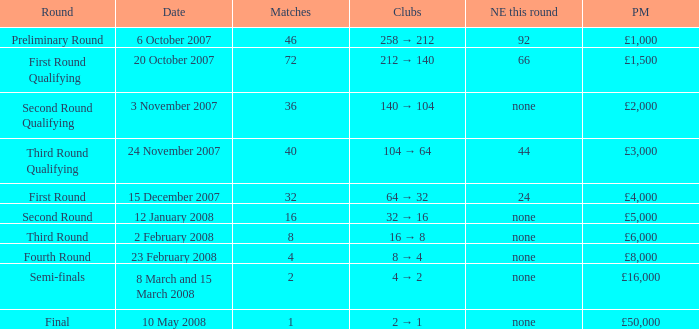What are the clubs with 46 matches? 258 → 212. 